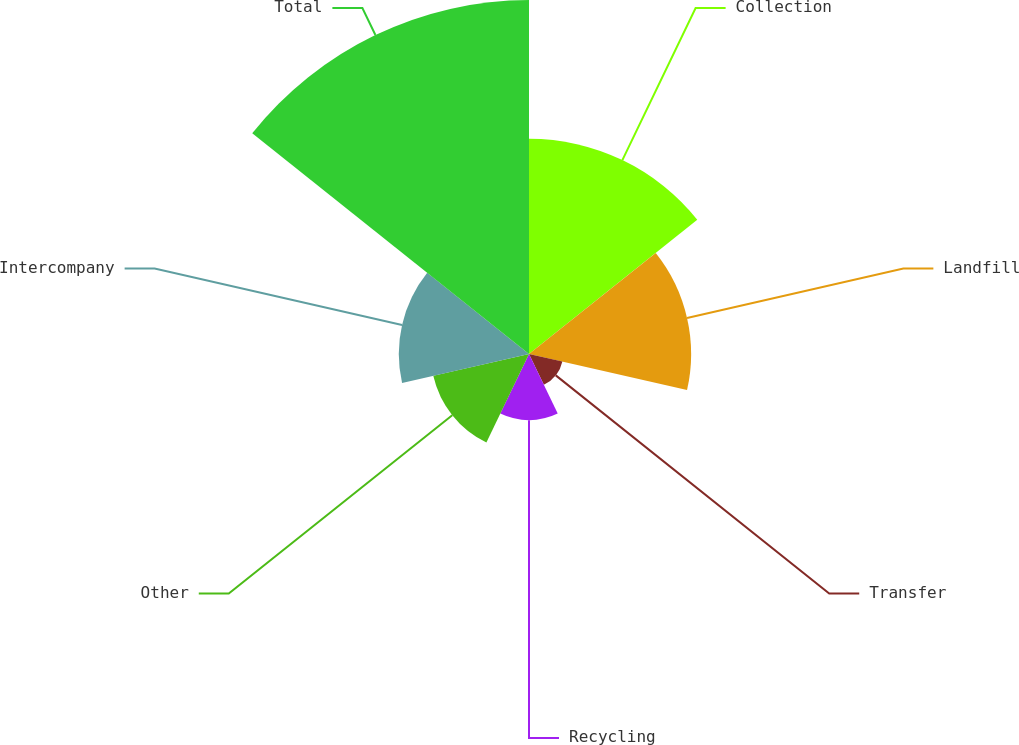Convert chart to OTSL. <chart><loc_0><loc_0><loc_500><loc_500><pie_chart><fcel>Collection<fcel>Landfill<fcel>Transfer<fcel>Recycling<fcel>Other<fcel>Intercompany<fcel>Total<nl><fcel>20.3%<fcel>15.29%<fcel>3.23%<fcel>6.24%<fcel>9.26%<fcel>12.28%<fcel>33.39%<nl></chart> 